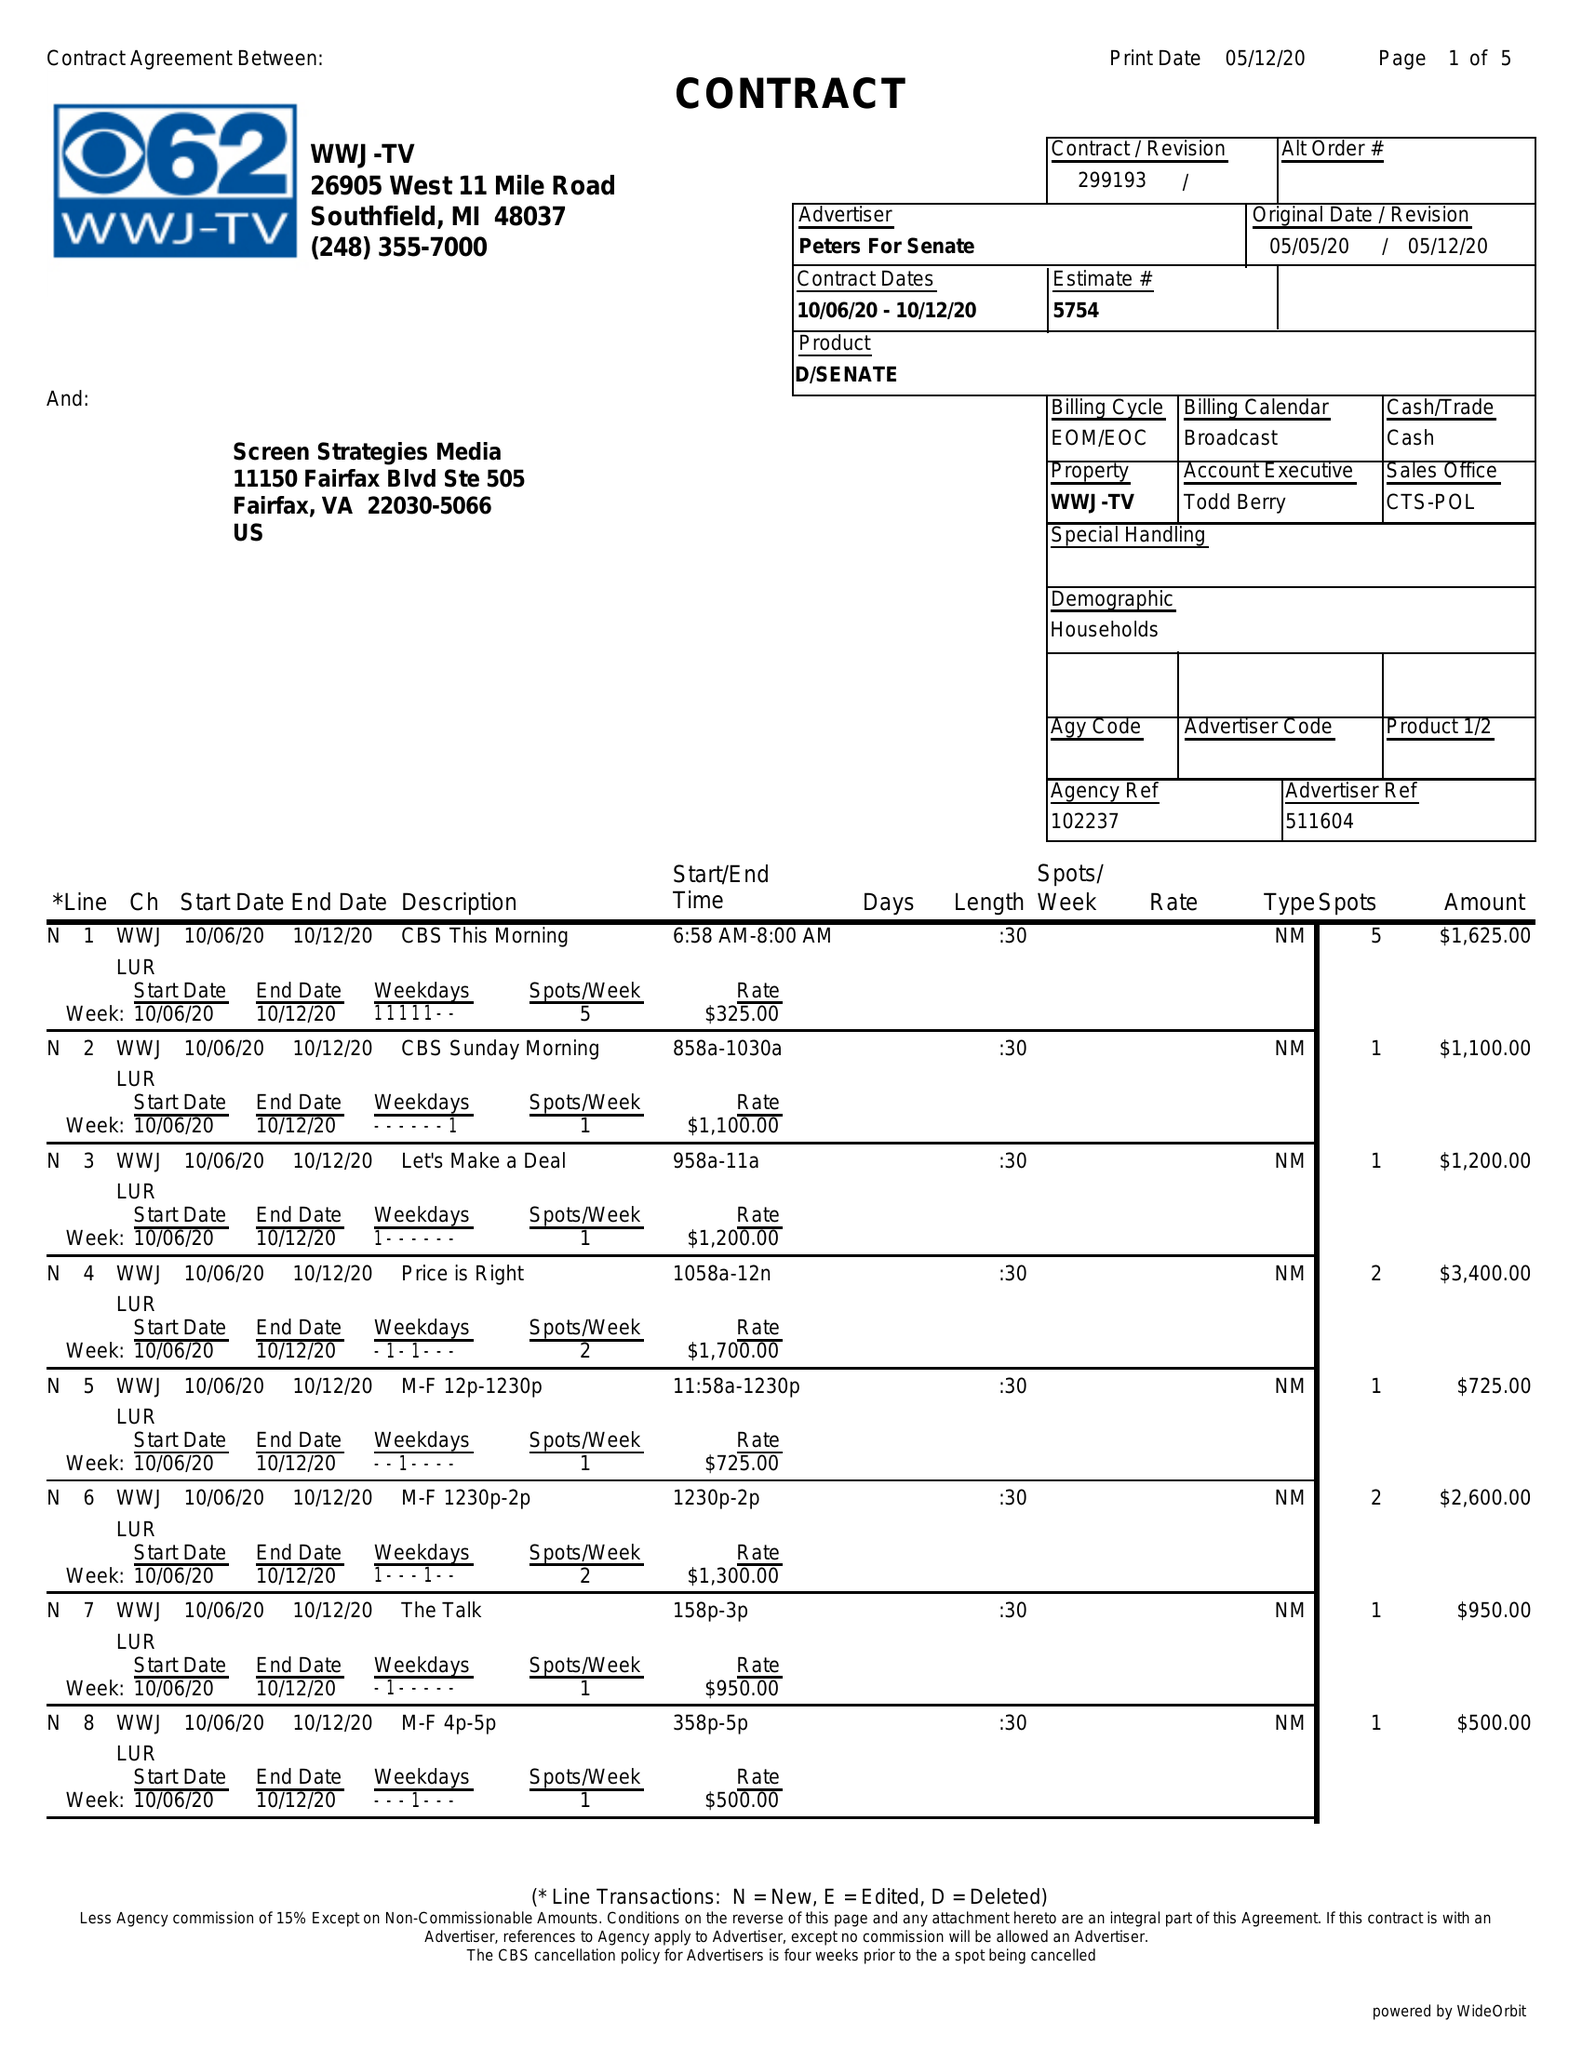What is the value for the flight_from?
Answer the question using a single word or phrase. 10/06/20 